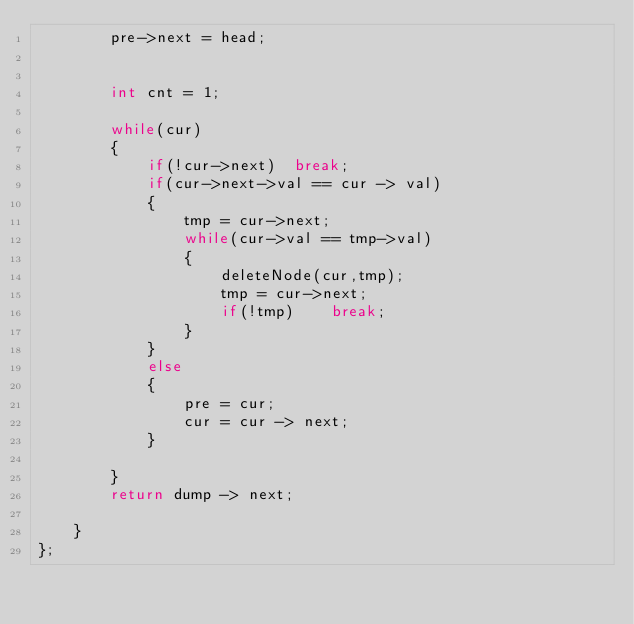Convert code to text. <code><loc_0><loc_0><loc_500><loc_500><_C++_>        pre->next = head;


        int cnt = 1;

        while(cur)
        {
            if(!cur->next)  break;
            if(cur->next->val == cur -> val)
            {
                tmp = cur->next;
                while(cur->val == tmp->val)
                {
                    deleteNode(cur,tmp);
                    tmp = cur->next;
                    if(!tmp)    break;
                }
            }
            else
            {
                pre = cur;
                cur = cur -> next;
            }
            
        }
        return dump -> next;

    }
};</code> 